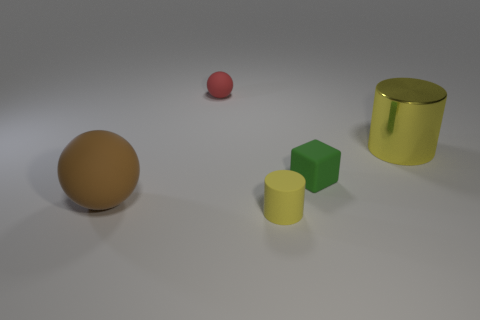What shape is the yellow object that is the same size as the green thing?
Your answer should be very brief. Cylinder. There is a large object that is to the left of the tiny rubber thing in front of the rubber sphere in front of the big metal cylinder; what is its color?
Your response must be concise. Brown. What number of objects are big yellow shiny objects behind the tiny yellow matte object or big blue rubber blocks?
Give a very brief answer. 1. There is a yellow cylinder that is the same size as the cube; what is it made of?
Your answer should be compact. Rubber. What is the cylinder in front of the cylinder to the right of the yellow cylinder that is left of the large metal thing made of?
Make the answer very short. Rubber. What color is the small matte ball?
Offer a terse response. Red. What number of large objects are purple matte cylinders or red objects?
Keep it short and to the point. 0. There is a tiny thing that is the same color as the shiny cylinder; what is its material?
Offer a very short reply. Rubber. Is the material of the sphere behind the yellow shiny object the same as the brown ball that is on the left side of the big yellow thing?
Your answer should be compact. Yes. Are there any rubber blocks?
Your response must be concise. Yes. 